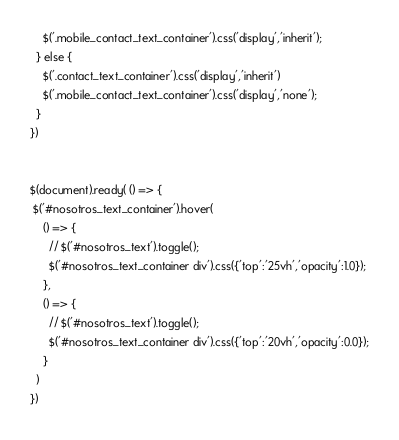<code> <loc_0><loc_0><loc_500><loc_500><_JavaScript_>    $('.mobile_contact_text_container').css('display','inherit');
  } else {
    $('.contact_text_container').css('display','inherit')
    $('.mobile_contact_text_container').css('display','none');
  }
})


$(document).ready( () => {
 $('#nosotros_text_container').hover(
    () => {
      // $('#nosotros_text').toggle();
      $('#nosotros_text_container div').css({'top':'25vh','opacity':1.0});
    },
    () => {
      // $('#nosotros_text').toggle();
      $('#nosotros_text_container div').css({'top':'20vh','opacity':0.0});
    }
  )
})
</code> 